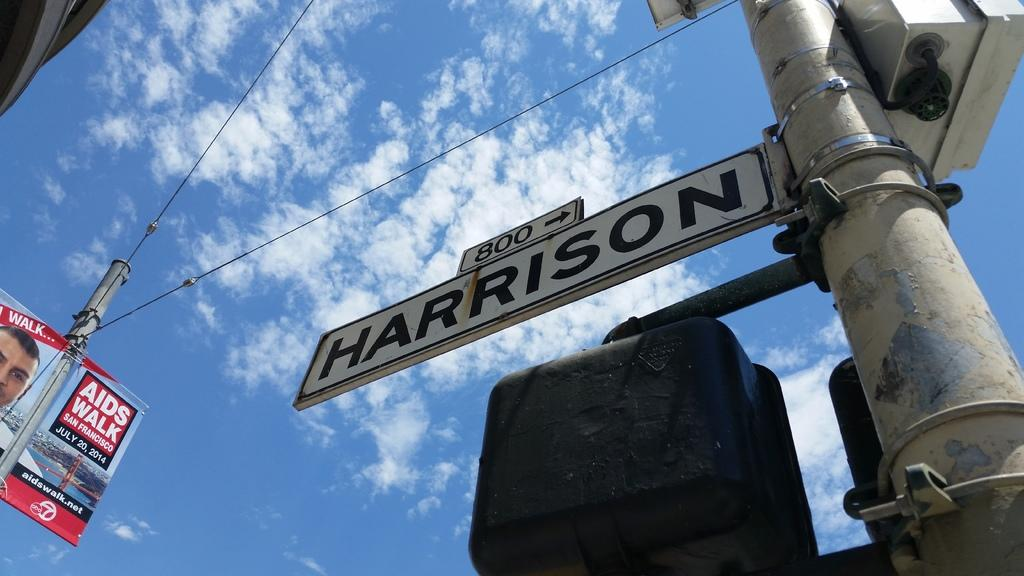<image>
Provide a brief description of the given image. The 800 block of Harrison is located to the right. 